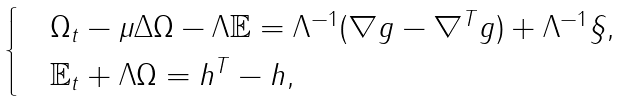<formula> <loc_0><loc_0><loc_500><loc_500>\begin{cases} & \Omega _ { t } - \mu \Delta \Omega - \Lambda \mathbb { E } = \Lambda ^ { - 1 } ( \nabla g - \nabla ^ { T } g ) + \Lambda ^ { - 1 } \S , \\ & \mathbb { E } _ { t } + \Lambda \Omega = h ^ { T } - h , \end{cases}</formula> 